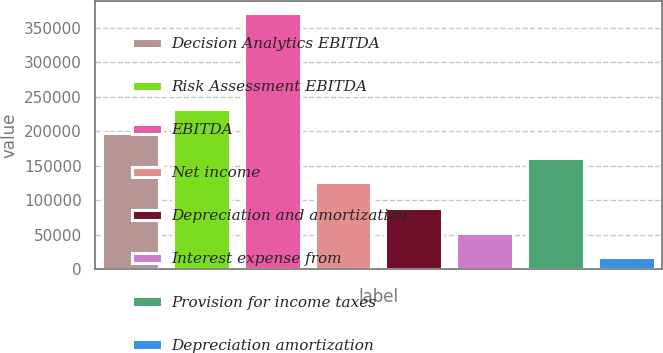Convert chart to OTSL. <chart><loc_0><loc_0><loc_500><loc_500><bar_chart><fcel>Decision Analytics EBITDA<fcel>Risk Assessment EBITDA<fcel>EBITDA<fcel>Net income<fcel>Depreciation and amortization<fcel>Interest expense from<fcel>Provision for income taxes<fcel>Depreciation amortization<nl><fcel>197334<fcel>232695<fcel>371069<fcel>126614<fcel>88187.4<fcel>52827.2<fcel>161974<fcel>17467<nl></chart> 